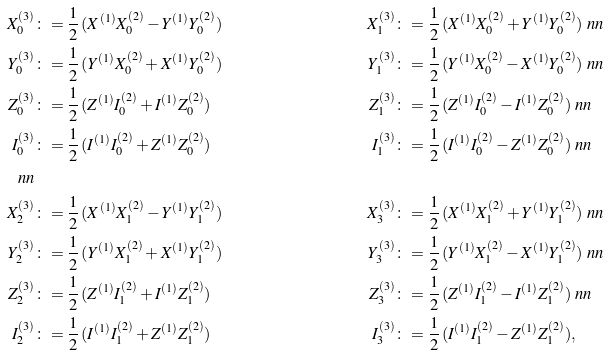<formula> <loc_0><loc_0><loc_500><loc_500>X _ { 0 } ^ { ( 3 ) } & \colon = \frac { 1 } { 2 } \, ( X ^ { ( 1 ) } X ^ { ( 2 ) } _ { 0 } - Y ^ { ( 1 ) } Y ^ { ( 2 ) } _ { 0 } ) & { X } _ { 1 } ^ { ( 3 ) } & \colon = \frac { 1 } { 2 } \, ( X ^ { ( 1 ) } { X } ^ { ( 2 ) } _ { 0 } + Y ^ { ( 1 ) } Y ^ { ( 2 ) } _ { 0 } ) \ n n \\ Y _ { 0 } ^ { ( 3 ) } & \colon = \frac { 1 } { 2 } \, ( Y ^ { ( 1 ) } X ^ { ( 2 ) } _ { 0 } + X ^ { ( 1 ) } Y ^ { ( 2 ) } _ { 0 } ) & { Y } _ { 1 } ^ { ( 3 ) } & \colon = \frac { 1 } { 2 } \, ( Y ^ { ( 1 ) } X ^ { ( 2 ) } _ { 0 } - X ^ { ( 1 ) } Y ^ { ( 2 ) } _ { 0 } ) \ n n \\ Z _ { 0 } ^ { ( 3 ) } & \colon = \frac { 1 } { 2 } \, ( Z ^ { ( 1 ) } I ^ { ( 2 ) } _ { 0 } + I ^ { ( 1 ) } Z ^ { ( 2 ) } _ { 0 } ) & { Z } _ { 1 } ^ { ( 3 ) } & \colon = \frac { 1 } { 2 } \, ( Z ^ { ( 1 ) } I ^ { ( 2 ) } _ { 0 } - I ^ { ( 1 ) } Z ^ { ( 2 ) } _ { 0 } ) \ n n \\ I _ { 0 } ^ { ( 3 ) } & \colon = \frac { 1 } { 2 } \, ( I ^ { ( 1 ) } I ^ { ( 2 ) } _ { 0 } + Z ^ { ( 1 ) } Z ^ { ( 2 ) } _ { 0 } ) & { I } _ { 1 } ^ { ( 3 ) } & \colon = \frac { 1 } { 2 } \, ( I ^ { ( 1 ) } { I } ^ { ( 2 ) } _ { 0 } - Z ^ { ( 1 ) } Z ^ { ( 2 ) } _ { 0 } ) \ n n \\ \ n n \\ X _ { 2 } ^ { ( 3 ) } & \colon = \frac { 1 } { 2 } \, ( X ^ { ( 1 ) } X ^ { ( 2 ) } _ { 1 } - Y ^ { ( 1 ) } Y ^ { ( 2 ) } _ { 1 } ) & X _ { 3 } ^ { ( 3 ) } & \colon = \frac { 1 } { 2 } \, ( X ^ { ( 1 ) } X ^ { ( 2 ) } _ { 1 } + Y ^ { ( 1 ) } Y ^ { ( 2 ) } _ { 1 } ) \ n n \\ Y ^ { ( 3 ) } _ { 2 } & \colon = \frac { 1 } { 2 } \, ( Y ^ { ( 1 ) } { X } ^ { ( 2 ) } _ { 1 } + X ^ { ( 1 ) } { Y } ^ { ( 2 ) } _ { 1 } ) & Y _ { 3 } ^ { ( 3 ) } & \colon = \frac { 1 } { 2 } \, ( Y ^ { ( 1 ) } { X } ^ { ( 2 ) } _ { 1 } - X ^ { ( 1 ) } { Y } ^ { ( 2 ) } _ { 1 } ) \ n n \\ Z _ { 2 } ^ { ( 3 ) } & \colon = \frac { 1 } { 2 } \, ( Z ^ { ( 1 ) } { I } ^ { ( 2 ) } _ { 1 } + I ^ { ( 1 ) } { Z } ^ { ( 2 ) } _ { 1 } ) & Z _ { 3 } ^ { ( 3 ) } & \colon = \frac { 1 } { 2 } \, ( Z ^ { ( 1 ) } { I } ^ { ( 2 ) } _ { 1 } - I ^ { ( 1 ) } { Z } ^ { ( 2 ) } _ { 1 } ) \ n n \\ I _ { 2 } ^ { ( 3 ) } & \colon = \frac { 1 } { 2 } \, ( I ^ { ( 1 ) } { I } ^ { ( 2 ) } _ { 1 } + Z ^ { ( 1 ) } Z ^ { ( 2 ) } _ { 1 } ) & I ^ { ( 3 ) } _ { 3 } & \colon = \frac { 1 } { 2 } \, ( I ^ { ( 1 ) } { I } ^ { ( 2 ) } _ { 1 } - Z ^ { ( 1 ) } { Z } ^ { ( 2 ) } _ { 1 } ) ,</formula> 